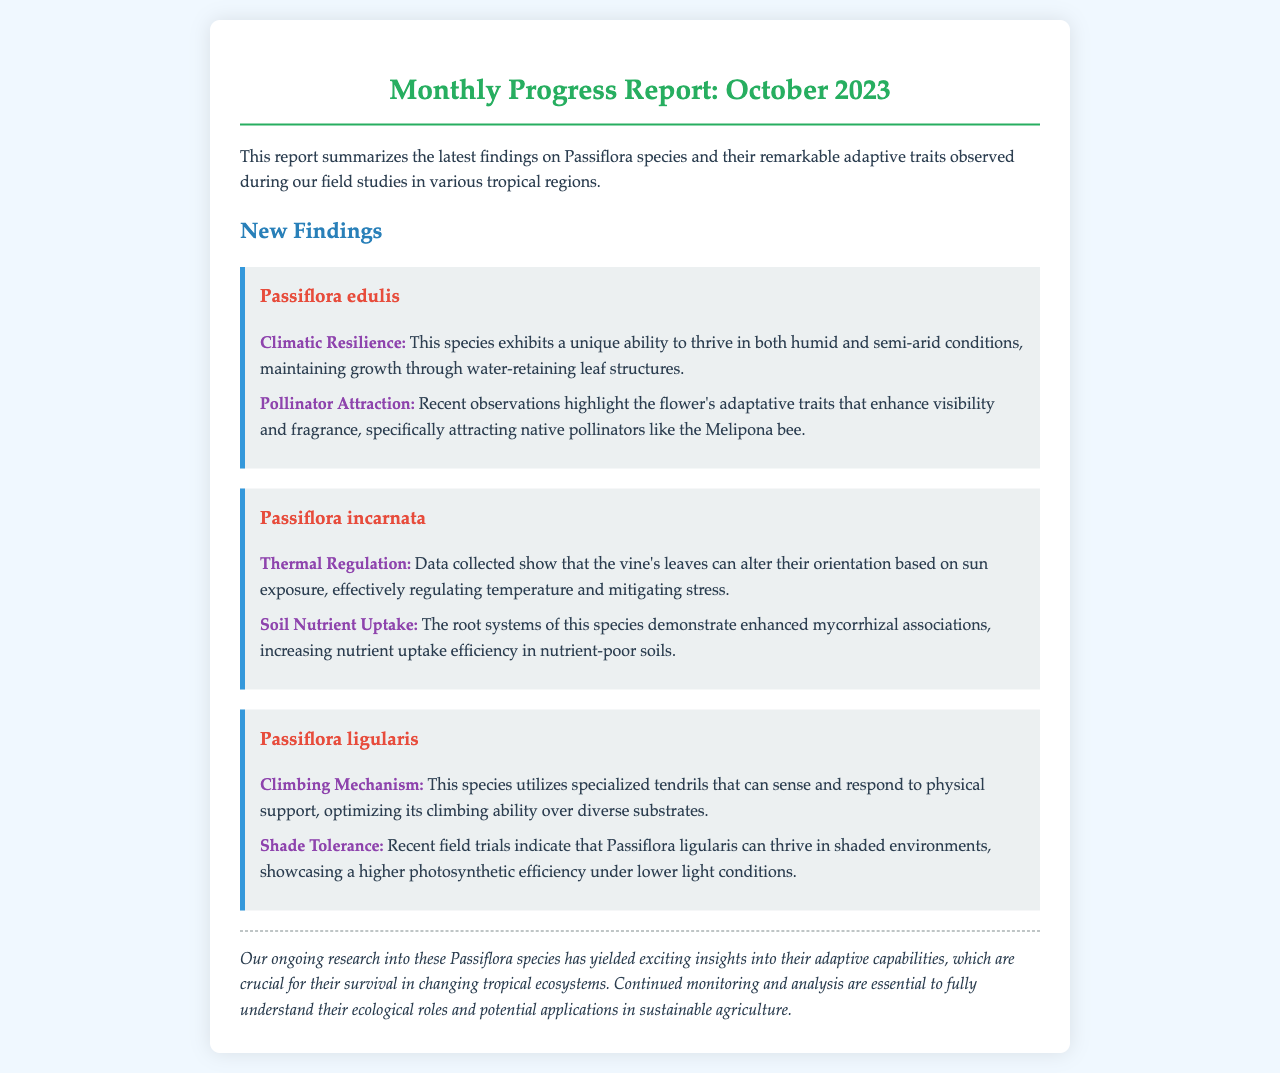What is the title of the report? The title of the report is displayed prominently at the top of the document.
Answer: Monthly Progress Report: October 2023 Which species exhibits climatic resilience? The document lists several species and their adaptive traits, specifying which one has this characteristic.
Answer: Passiflora edulis How does Passiflora incarnata regulate temperature? Details in the document describe how this species adaptively alters leaf orientation for thermal regulation.
Answer: Alters leaf orientation What unique mechanism does Passiflora ligularis utilize for climbing? The report outlines the adaptive traits, including climbing mechanisms specific to this species.
Answer: Specialized tendrils What is a notable trait of Passiflora edulis in attracting pollinators? The document specifies certain adaptive traits that enhance visibility and fragrance for pollinator attraction.
Answer: Enhanced visibility and fragrance What adaptation allows Passiflora incarnata to increase nutrient uptake? The document describes root system improvements that aid in nutrient uptake under challenging soil conditions.
Answer: Mycorrhizal associations What characteristic is highlighted for Passiflora ligularis in shaded environments? The report mentions how this species performs in lower light conditions, indicating a specific adaptive trait.
Answer: Higher photosynthetic efficiency What is the overarching conclusion of the report? The document concludes with a summary of the significance of the findings in relation to ecological roles and agriculture.
Answer: Exciting insights into their adaptive capabilities 